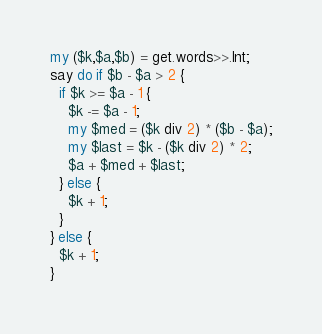Convert code to text. <code><loc_0><loc_0><loc_500><loc_500><_Perl_>my ($k,$a,$b) = get.words>>.Int;
say do if $b - $a > 2 {
  if $k >= $a - 1 {
    $k -= $a - 1;
    my $med = ($k div 2) * ($b - $a);
    my $last = $k - ($k div 2) * 2;
    $a + $med + $last;
  } else {
    $k + 1;
  }
} else {
  $k + 1;
}
</code> 